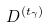<formula> <loc_0><loc_0><loc_500><loc_500>D ^ { ( t _ { \gamma } ) }</formula> 